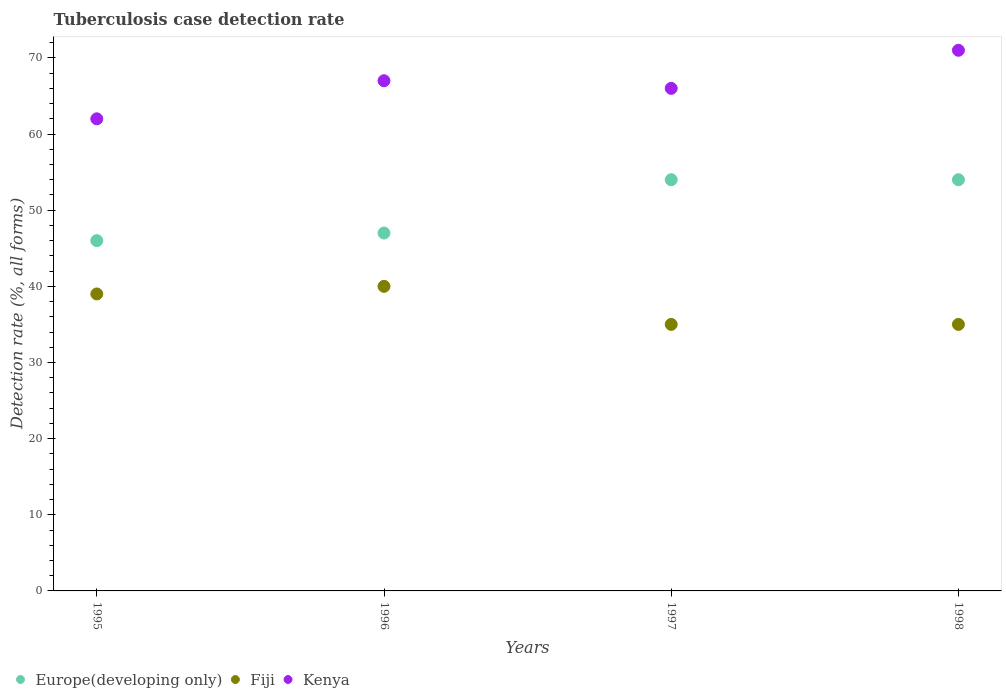What is the tuberculosis case detection rate in in Europe(developing only) in 1995?
Provide a succinct answer. 46. Across all years, what is the maximum tuberculosis case detection rate in in Kenya?
Your answer should be compact. 71. Across all years, what is the minimum tuberculosis case detection rate in in Europe(developing only)?
Make the answer very short. 46. What is the total tuberculosis case detection rate in in Kenya in the graph?
Your response must be concise. 266. What is the difference between the tuberculosis case detection rate in in Europe(developing only) in 1995 and that in 1996?
Make the answer very short. -1. What is the difference between the tuberculosis case detection rate in in Fiji in 1997 and the tuberculosis case detection rate in in Europe(developing only) in 1996?
Provide a short and direct response. -12. What is the average tuberculosis case detection rate in in Kenya per year?
Make the answer very short. 66.5. In the year 1998, what is the difference between the tuberculosis case detection rate in in Europe(developing only) and tuberculosis case detection rate in in Fiji?
Your response must be concise. 19. In how many years, is the tuberculosis case detection rate in in Kenya greater than 68 %?
Offer a very short reply. 1. What is the ratio of the tuberculosis case detection rate in in Kenya in 1996 to that in 1997?
Offer a terse response. 1.02. Is the difference between the tuberculosis case detection rate in in Europe(developing only) in 1995 and 1996 greater than the difference between the tuberculosis case detection rate in in Fiji in 1995 and 1996?
Give a very brief answer. No. What is the difference between the highest and the second highest tuberculosis case detection rate in in Fiji?
Your answer should be compact. 1. What is the difference between the highest and the lowest tuberculosis case detection rate in in Fiji?
Make the answer very short. 5. Is it the case that in every year, the sum of the tuberculosis case detection rate in in Europe(developing only) and tuberculosis case detection rate in in Fiji  is greater than the tuberculosis case detection rate in in Kenya?
Your answer should be compact. Yes. Does the tuberculosis case detection rate in in Fiji monotonically increase over the years?
Give a very brief answer. No. Are the values on the major ticks of Y-axis written in scientific E-notation?
Ensure brevity in your answer.  No. Does the graph contain any zero values?
Your answer should be very brief. No. How many legend labels are there?
Provide a succinct answer. 3. What is the title of the graph?
Your response must be concise. Tuberculosis case detection rate. What is the label or title of the Y-axis?
Your response must be concise. Detection rate (%, all forms). What is the Detection rate (%, all forms) in Europe(developing only) in 1995?
Make the answer very short. 46. What is the Detection rate (%, all forms) of Fiji in 1995?
Offer a terse response. 39. What is the Detection rate (%, all forms) of Europe(developing only) in 1996?
Offer a very short reply. 47. What is the Detection rate (%, all forms) in Fiji in 1996?
Provide a short and direct response. 40. What is the Detection rate (%, all forms) in Fiji in 1997?
Keep it short and to the point. 35. What is the Detection rate (%, all forms) in Kenya in 1997?
Your answer should be very brief. 66. What is the Detection rate (%, all forms) in Kenya in 1998?
Offer a terse response. 71. Across all years, what is the maximum Detection rate (%, all forms) of Kenya?
Your response must be concise. 71. Across all years, what is the minimum Detection rate (%, all forms) in Europe(developing only)?
Your response must be concise. 46. What is the total Detection rate (%, all forms) in Europe(developing only) in the graph?
Make the answer very short. 201. What is the total Detection rate (%, all forms) of Fiji in the graph?
Your response must be concise. 149. What is the total Detection rate (%, all forms) of Kenya in the graph?
Provide a short and direct response. 266. What is the difference between the Detection rate (%, all forms) of Kenya in 1995 and that in 1998?
Provide a succinct answer. -9. What is the difference between the Detection rate (%, all forms) of Europe(developing only) in 1996 and that in 1997?
Your answer should be very brief. -7. What is the difference between the Detection rate (%, all forms) of Fiji in 1996 and that in 1997?
Provide a succinct answer. 5. What is the difference between the Detection rate (%, all forms) in Europe(developing only) in 1996 and that in 1998?
Make the answer very short. -7. What is the difference between the Detection rate (%, all forms) of Fiji in 1997 and that in 1998?
Provide a succinct answer. 0. What is the difference between the Detection rate (%, all forms) in Europe(developing only) in 1995 and the Detection rate (%, all forms) in Kenya in 1996?
Offer a terse response. -21. What is the difference between the Detection rate (%, all forms) of Europe(developing only) in 1995 and the Detection rate (%, all forms) of Fiji in 1997?
Provide a succinct answer. 11. What is the difference between the Detection rate (%, all forms) of Europe(developing only) in 1995 and the Detection rate (%, all forms) of Kenya in 1997?
Keep it short and to the point. -20. What is the difference between the Detection rate (%, all forms) of Fiji in 1995 and the Detection rate (%, all forms) of Kenya in 1997?
Offer a very short reply. -27. What is the difference between the Detection rate (%, all forms) of Europe(developing only) in 1995 and the Detection rate (%, all forms) of Fiji in 1998?
Make the answer very short. 11. What is the difference between the Detection rate (%, all forms) in Fiji in 1995 and the Detection rate (%, all forms) in Kenya in 1998?
Your answer should be very brief. -32. What is the difference between the Detection rate (%, all forms) in Europe(developing only) in 1996 and the Detection rate (%, all forms) in Kenya in 1997?
Provide a succinct answer. -19. What is the difference between the Detection rate (%, all forms) of Fiji in 1996 and the Detection rate (%, all forms) of Kenya in 1997?
Ensure brevity in your answer.  -26. What is the difference between the Detection rate (%, all forms) of Europe(developing only) in 1996 and the Detection rate (%, all forms) of Kenya in 1998?
Give a very brief answer. -24. What is the difference between the Detection rate (%, all forms) in Fiji in 1996 and the Detection rate (%, all forms) in Kenya in 1998?
Keep it short and to the point. -31. What is the difference between the Detection rate (%, all forms) of Europe(developing only) in 1997 and the Detection rate (%, all forms) of Fiji in 1998?
Keep it short and to the point. 19. What is the difference between the Detection rate (%, all forms) in Fiji in 1997 and the Detection rate (%, all forms) in Kenya in 1998?
Provide a succinct answer. -36. What is the average Detection rate (%, all forms) of Europe(developing only) per year?
Your answer should be compact. 50.25. What is the average Detection rate (%, all forms) in Fiji per year?
Provide a succinct answer. 37.25. What is the average Detection rate (%, all forms) in Kenya per year?
Your answer should be compact. 66.5. In the year 1995, what is the difference between the Detection rate (%, all forms) in Europe(developing only) and Detection rate (%, all forms) in Fiji?
Your answer should be compact. 7. In the year 1995, what is the difference between the Detection rate (%, all forms) of Fiji and Detection rate (%, all forms) of Kenya?
Keep it short and to the point. -23. In the year 1996, what is the difference between the Detection rate (%, all forms) in Europe(developing only) and Detection rate (%, all forms) in Fiji?
Offer a terse response. 7. In the year 1997, what is the difference between the Detection rate (%, all forms) in Europe(developing only) and Detection rate (%, all forms) in Fiji?
Ensure brevity in your answer.  19. In the year 1997, what is the difference between the Detection rate (%, all forms) in Fiji and Detection rate (%, all forms) in Kenya?
Give a very brief answer. -31. In the year 1998, what is the difference between the Detection rate (%, all forms) of Fiji and Detection rate (%, all forms) of Kenya?
Offer a very short reply. -36. What is the ratio of the Detection rate (%, all forms) in Europe(developing only) in 1995 to that in 1996?
Provide a succinct answer. 0.98. What is the ratio of the Detection rate (%, all forms) of Kenya in 1995 to that in 1996?
Offer a terse response. 0.93. What is the ratio of the Detection rate (%, all forms) in Europe(developing only) in 1995 to that in 1997?
Ensure brevity in your answer.  0.85. What is the ratio of the Detection rate (%, all forms) in Fiji in 1995 to that in 1997?
Offer a very short reply. 1.11. What is the ratio of the Detection rate (%, all forms) in Kenya in 1995 to that in 1997?
Your response must be concise. 0.94. What is the ratio of the Detection rate (%, all forms) in Europe(developing only) in 1995 to that in 1998?
Your response must be concise. 0.85. What is the ratio of the Detection rate (%, all forms) of Fiji in 1995 to that in 1998?
Provide a short and direct response. 1.11. What is the ratio of the Detection rate (%, all forms) of Kenya in 1995 to that in 1998?
Offer a very short reply. 0.87. What is the ratio of the Detection rate (%, all forms) in Europe(developing only) in 1996 to that in 1997?
Offer a terse response. 0.87. What is the ratio of the Detection rate (%, all forms) of Kenya in 1996 to that in 1997?
Offer a terse response. 1.02. What is the ratio of the Detection rate (%, all forms) of Europe(developing only) in 1996 to that in 1998?
Provide a succinct answer. 0.87. What is the ratio of the Detection rate (%, all forms) in Fiji in 1996 to that in 1998?
Your answer should be compact. 1.14. What is the ratio of the Detection rate (%, all forms) of Kenya in 1996 to that in 1998?
Your answer should be very brief. 0.94. What is the ratio of the Detection rate (%, all forms) of Kenya in 1997 to that in 1998?
Give a very brief answer. 0.93. What is the difference between the highest and the lowest Detection rate (%, all forms) of Europe(developing only)?
Make the answer very short. 8. 